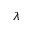<formula> <loc_0><loc_0><loc_500><loc_500>\lambda</formula> 